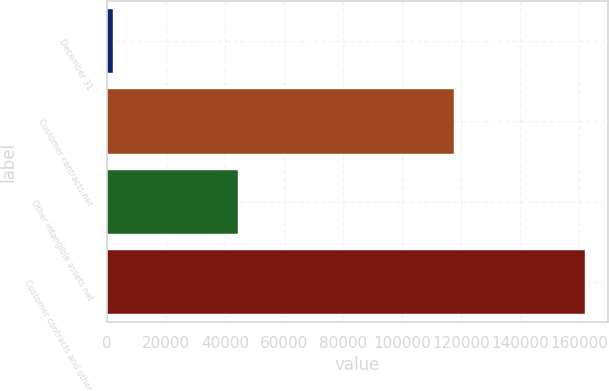Convert chart to OTSL. <chart><loc_0><loc_0><loc_500><loc_500><bar_chart><fcel>December 31<fcel>Customer contracts net<fcel>Other intangible assets net<fcel>Customer contracts and other<nl><fcel>2016<fcel>117466<fcel>44310<fcel>161776<nl></chart> 